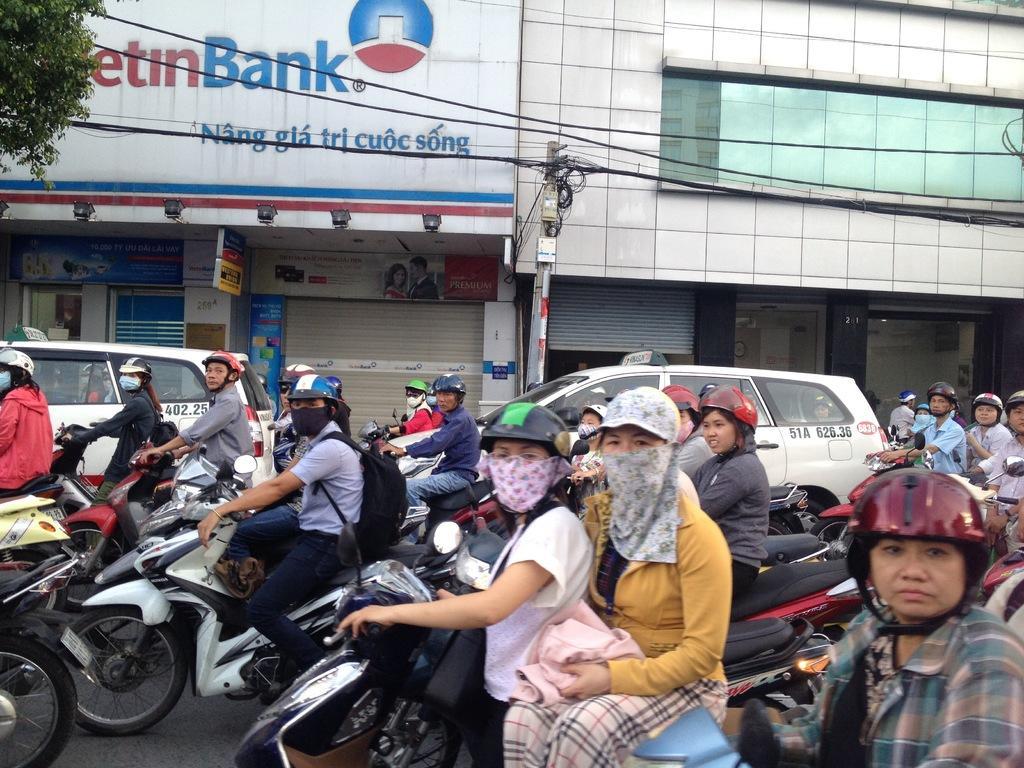Describe this image in one or two sentences. This picture describes about group of people riding bikes on the road, and we can see couple of cars, pole, couple of buildings and trees. 